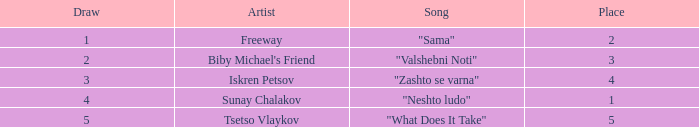What is the highest draw when the place is less than 3 and the percentage is 30.71%? 1.0. 